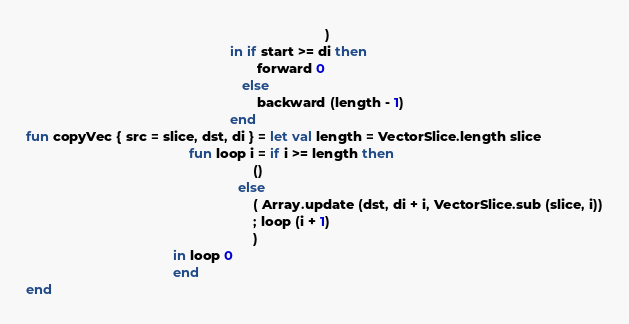Convert code to text. <code><loc_0><loc_0><loc_500><loc_500><_SML_>                                                                               )
                                                      in if start >= di then
                                                             forward 0
                                                         else
                                                             backward (length - 1)
                                                      end
fun copyVec { src = slice, dst, di } = let val length = VectorSlice.length slice
                                           fun loop i = if i >= length then
                                                            ()
                                                        else
                                                            ( Array.update (dst, di + i, VectorSlice.sub (slice, i))
                                                            ; loop (i + 1)
                                                            )
                                       in loop 0
                                       end
end
</code> 